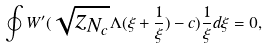Convert formula to latex. <formula><loc_0><loc_0><loc_500><loc_500>\oint W ^ { \prime } ( \sqrt { z _ { N _ { c } } } \Lambda ( \xi + \frac { 1 } { \xi } ) - c ) \frac { 1 } { \xi } d \xi = 0 ,</formula> 